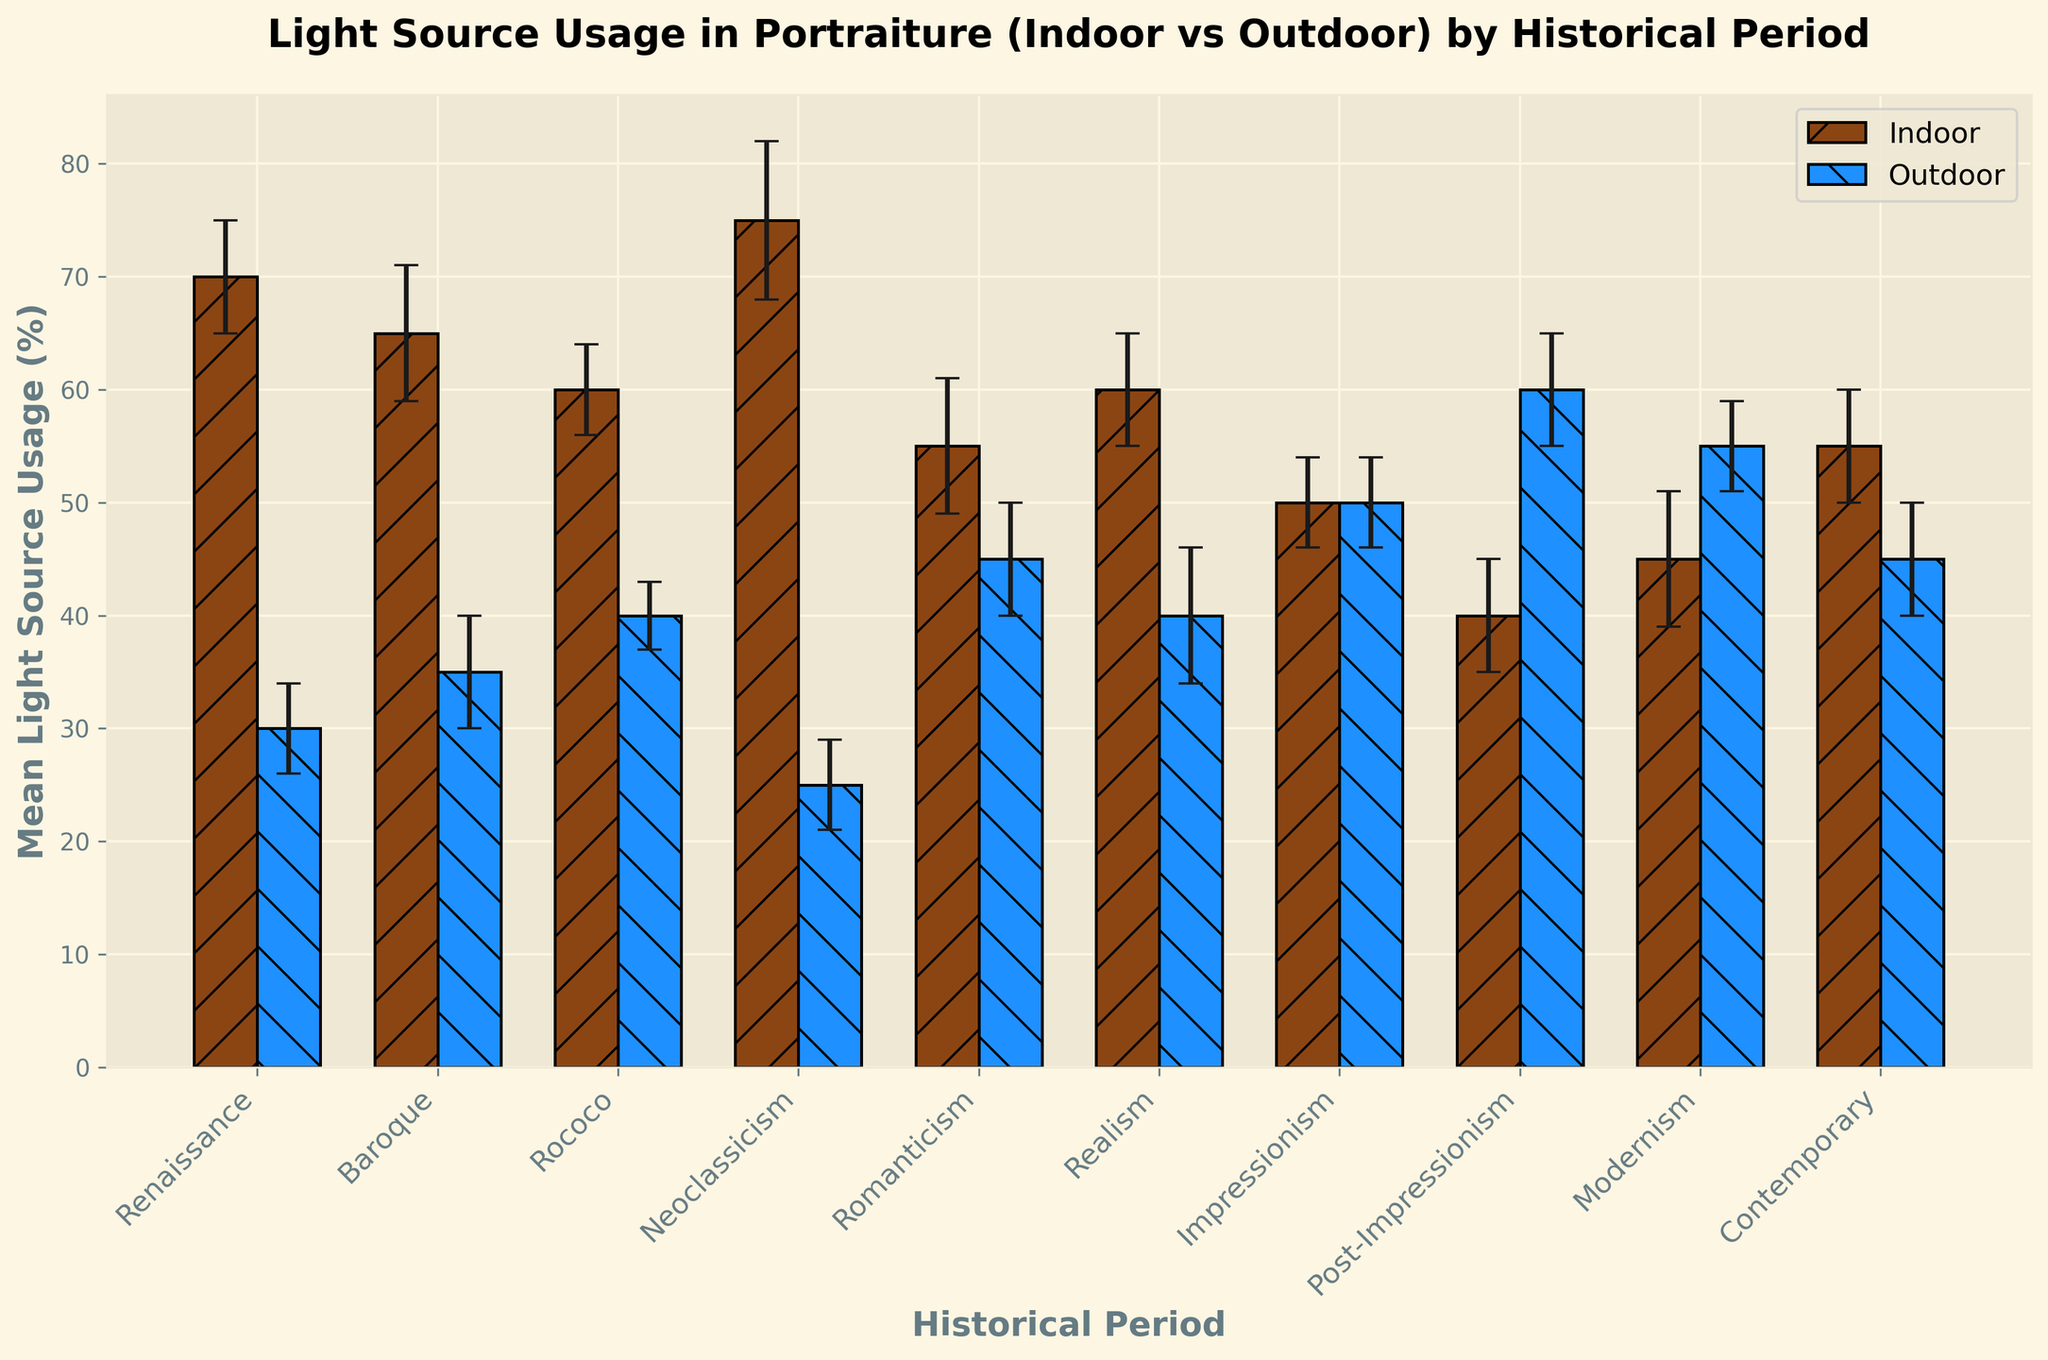Which historical period has the highest indoor light source usage? Look for the tallest bar labeled 'Indoor'. Neoclassicism has the highest indoor light source usage with its bar reaching 75%.
Answer: Neoclassicism What is the difference in light source usage between indoor and outdoor during the Baroque period? Subtract the value of the outdoor bar from the indoor bar for the Baroque period: 65% (indoor) - 35% (outdoor) = 30%.
Answer: 30% In which historical period is the light source usage equal for both indoor and outdoor settings? Identify the period where the heights of the indoor and outdoor bars are the same. For Impressionism, indoor and outdoor both have a usage of 50%.
Answer: Impressionism Which period sees a decline in indoor light source usage followed by an increase in the subsequent period? Scan through the periods and note where the indoor bar decreases from one period to the next and then increases again. Indoor usage decreases from Rococo (60%) to Romanticism (55%), then increases to Realism (60%).
Answer: Romanticism During the Contemporary period, is the light source usage higher for indoor or outdoor settings, and by how much? Compare the heights of the indoor and outdoor bars for the Contemporary period. Indoor is 55% and outdoor is 45%, leading to a difference of 10%.
Answer: Indoor by 10% What is the average outdoor light source usage during Renaissance and Baroque periods? Add the outdoor light source usage for Renaissance (30%) and Baroque (35%), then divide by 2: (30% + 35%) / 2 = 32.5%.
Answer: 32.5% How does the standard deviation of indoor light source usage during Neoclassicism compare to that during Renaissance? Compare the error bars (standard deviation) of the indoor light source usage for both periods. Neoclassicism has a standard deviation of 7, and Renaissance has 5.
Answer: Neoclassicism is higher by 2 Which location has a higher variability in light source usage during the Rococo period? Compare the lengths of the error bars for Indoor and Outdoor in Rococo. Indoor has a standard deviation of 4, and Outdoor has 3.
Answer: Indoor What is the total light source usage for both indoor and outdoor settings during Realism? Add the light source usage for indoor and outdoor settings during Realism: 60% (indoor) + 40% (outdoor) = 100%.
Answer: 100% Which period shows a significant reversal in preferences for indoor and outdoor light source usage compared to the preceding period? Look for periods where the taller bar switches from indoor to outdoor or vice versa. This occurs from Post-Impressionism (Indoor 40%, Outdoor 60%) to Modernism (Indoor 45%, Outdoor 55%).
Answer: Post-Impressionism to Modernism 